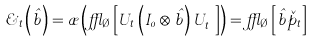<formula> <loc_0><loc_0><loc_500><loc_500>\varsigma _ { t } \left ( \hat { b } \right ) = \rho \left ( \epsilon _ { \emptyset } \left [ U _ { t } \left ( I _ { 0 } \otimes \hat { b } \right ) U _ { t } ^ { \dagger } \right ] \right ) = \epsilon _ { \emptyset } \left [ \hat { b } \check { p } _ { t } \right ]</formula> 